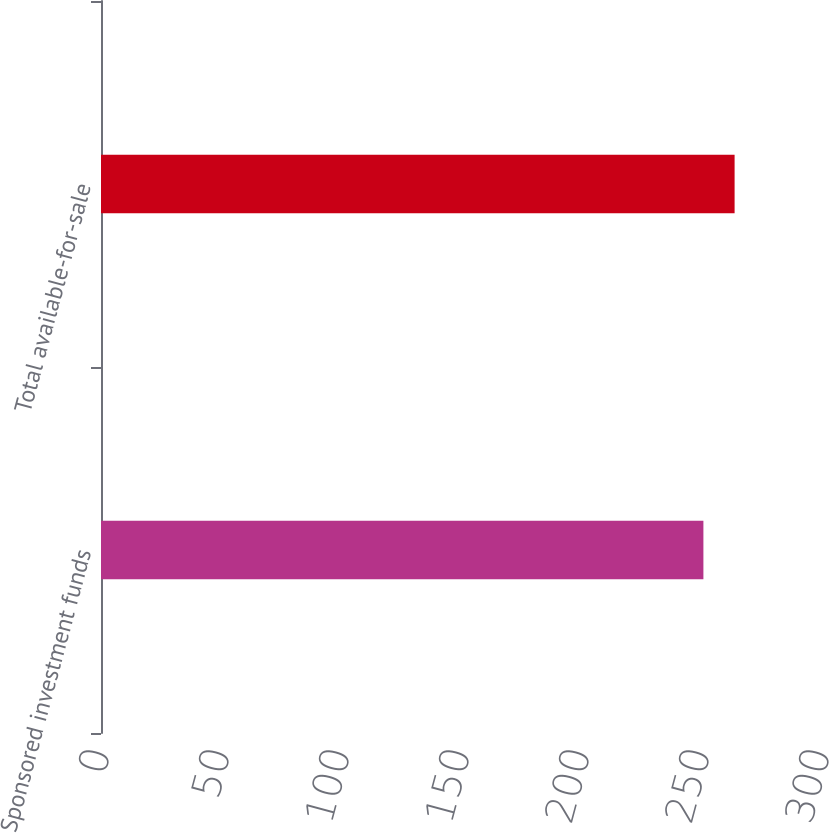Convert chart. <chart><loc_0><loc_0><loc_500><loc_500><bar_chart><fcel>Sponsored investment funds<fcel>Total available-for-sale<nl><fcel>251<fcel>264<nl></chart> 